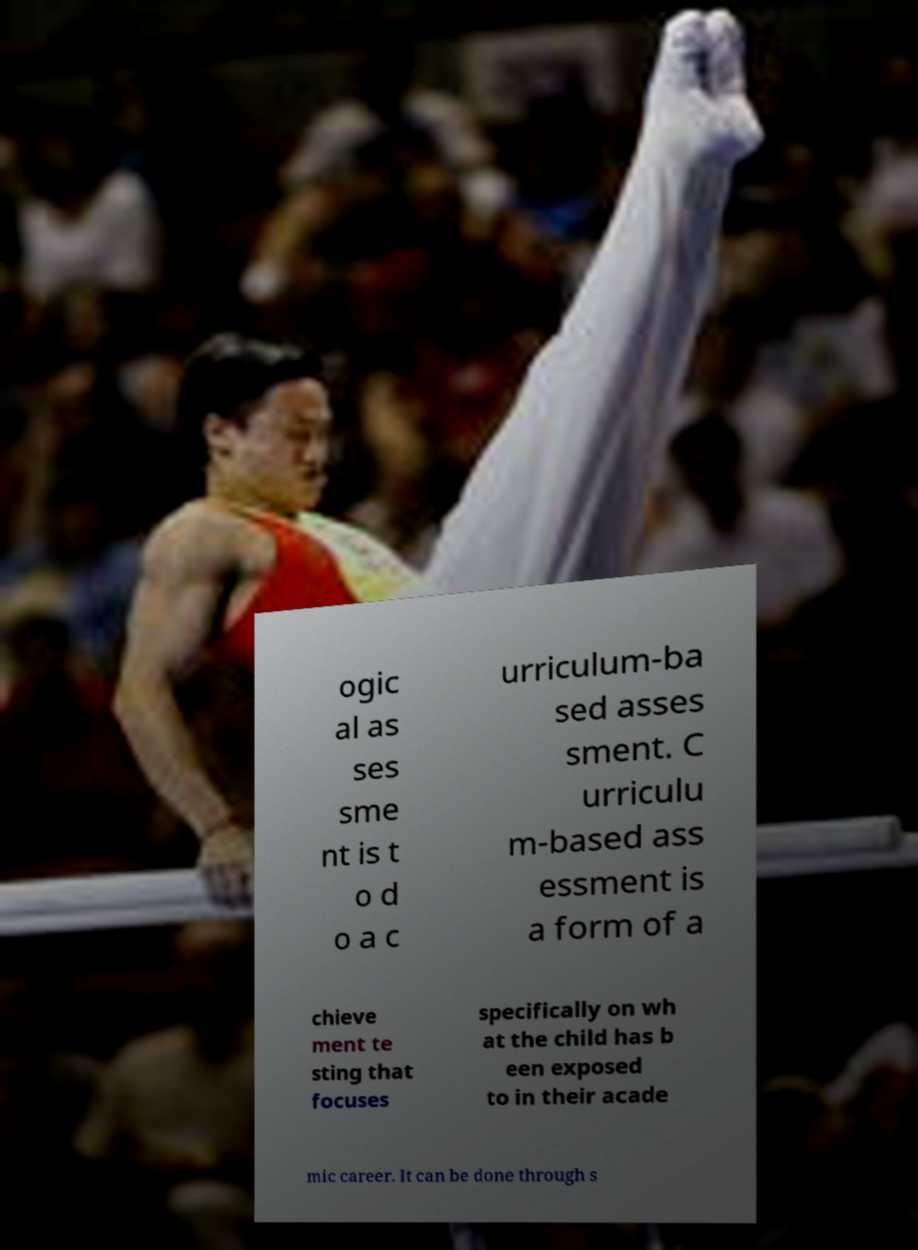There's text embedded in this image that I need extracted. Can you transcribe it verbatim? ogic al as ses sme nt is t o d o a c urriculum-ba sed asses sment. C urriculu m-based ass essment is a form of a chieve ment te sting that focuses specifically on wh at the child has b een exposed to in their acade mic career. It can be done through s 